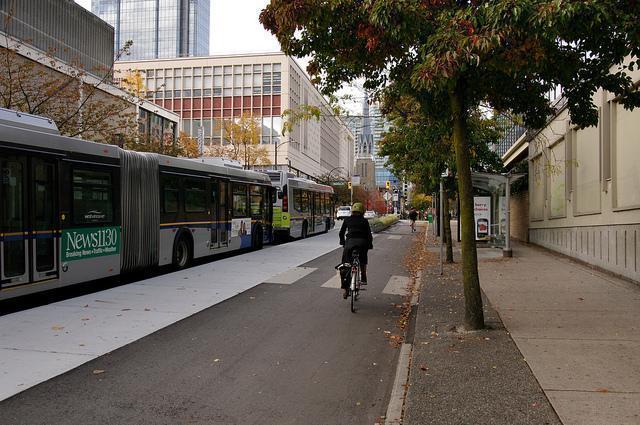What type of lane is shown?
Choose the correct response and explain in the format: 'Answer: answer
Rationale: rationale.'
Options: Fire, middle, passing, bike. Answer: bike.
Rationale: This is a narrow lane and people are riding bikes on it. 